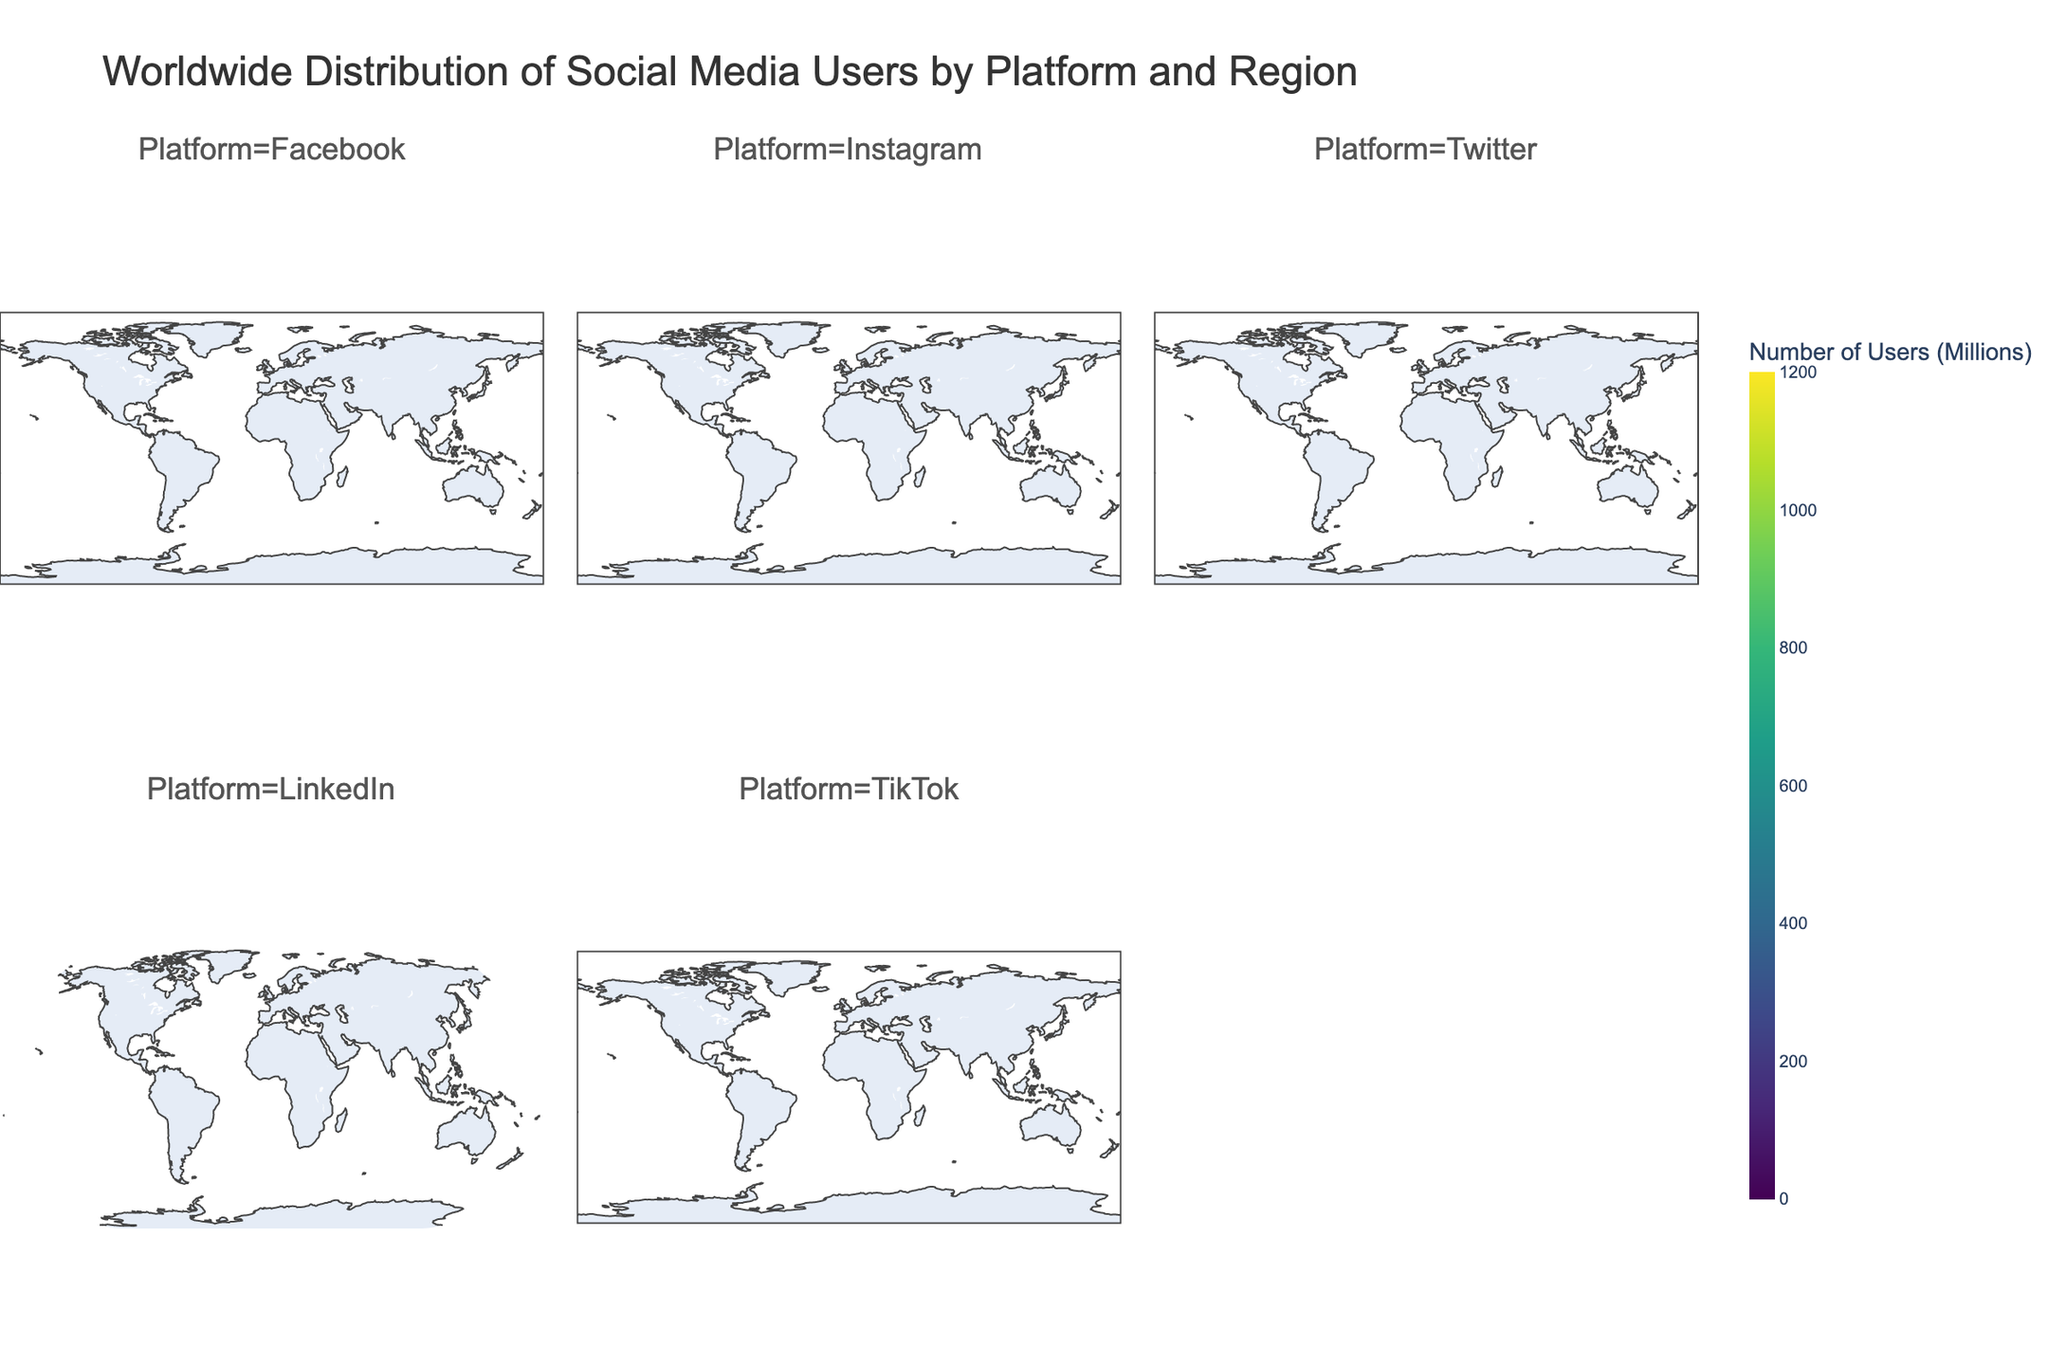What's the title of the figure? The title is usually prominently displayed at the top of the figure. By examining the top section of the figure, you can identify that the title is displayed clearly.
Answer: Worldwide Distribution of Social Media Users by Platform and Region Which region has the highest number of Facebook users? Locate the sections or facets of the figure that specifically correspond to Facebook. Check the color intensity for each region, focusing on the one that shows the highest intensity, which corresponds to the highest value.
Answer: Asia What is the total number of TikTok users in Europe and Asia combined? First, find the number of TikTok users in Europe and in Asia from the TikTok facet of the figure. Sum these two values: Europe has 196 users and Asia has 700 users. So, 196 + 700 = 896.
Answer: 896 Which social media platform has the least number of users in Oceania? Look for the smallest value in the Oceania section across all facets of the figure. Identify the facet (social media platform) with the lowest intensity of color for Oceania.
Answer: TikTok How does the number of Instagram users in South America compare to the number of LinkedIn users in North America? Find the values for Instagram users in South America and LinkedIn users in North America. Compare these two values: Instagram in South America has 180 users, and LinkedIn in North America has 191 users. 180 is less than 191.
Answer: Less Which region shows a similar number of Twitter users and LinkedIn users? Examine each region's Twitter and LinkedIn sections. Compare the values to find a region where the counts are closely matched or equal. Both values being in the same range can be considered similar. See Africa with Twitter (38) and LinkedIn (35).
Answer: Africa What is the average number of social media users for all platforms combined in North America? Sum the number of users for all platforms in North America and then divide by the number of platforms (5). Sum: 240 (Facebook) + 140 (Instagram) + 73 (Twitter) + 191 (LinkedIn) + 105 (TikTok) = 749. Average: 749 / 5 = 149.8.
Answer: 149.8 Which region has the most balanced distribution of users across the different social media platforms? Analyze the figure to see which region has the most even color distribution across all the platform facets. The region where colors are most evenly matched in intensity indicates a balanced distribution.
Answer: South America What's the difference in the number of Facebook users between Europe and Africa? Identify and subtract the number of Facebook users in Africa from Europe: Europe has 307 and Africa has 210. So, 307 - 210 = 97.
Answer: 97 